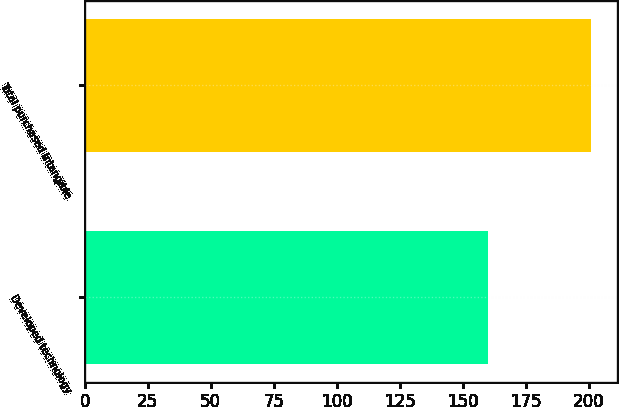Convert chart. <chart><loc_0><loc_0><loc_500><loc_500><bar_chart><fcel>Developed technology<fcel>Total purchased intangible<nl><fcel>160<fcel>201<nl></chart> 